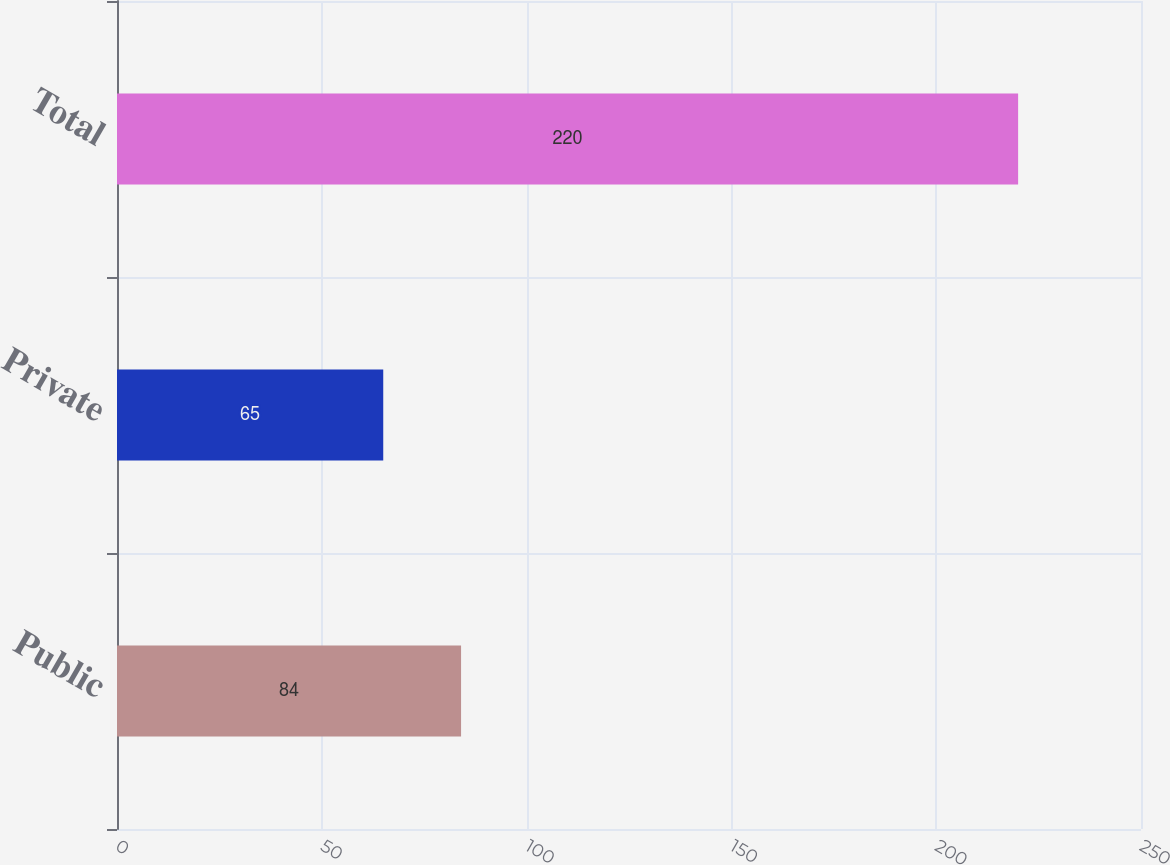<chart> <loc_0><loc_0><loc_500><loc_500><bar_chart><fcel>Public<fcel>Private<fcel>Total<nl><fcel>84<fcel>65<fcel>220<nl></chart> 